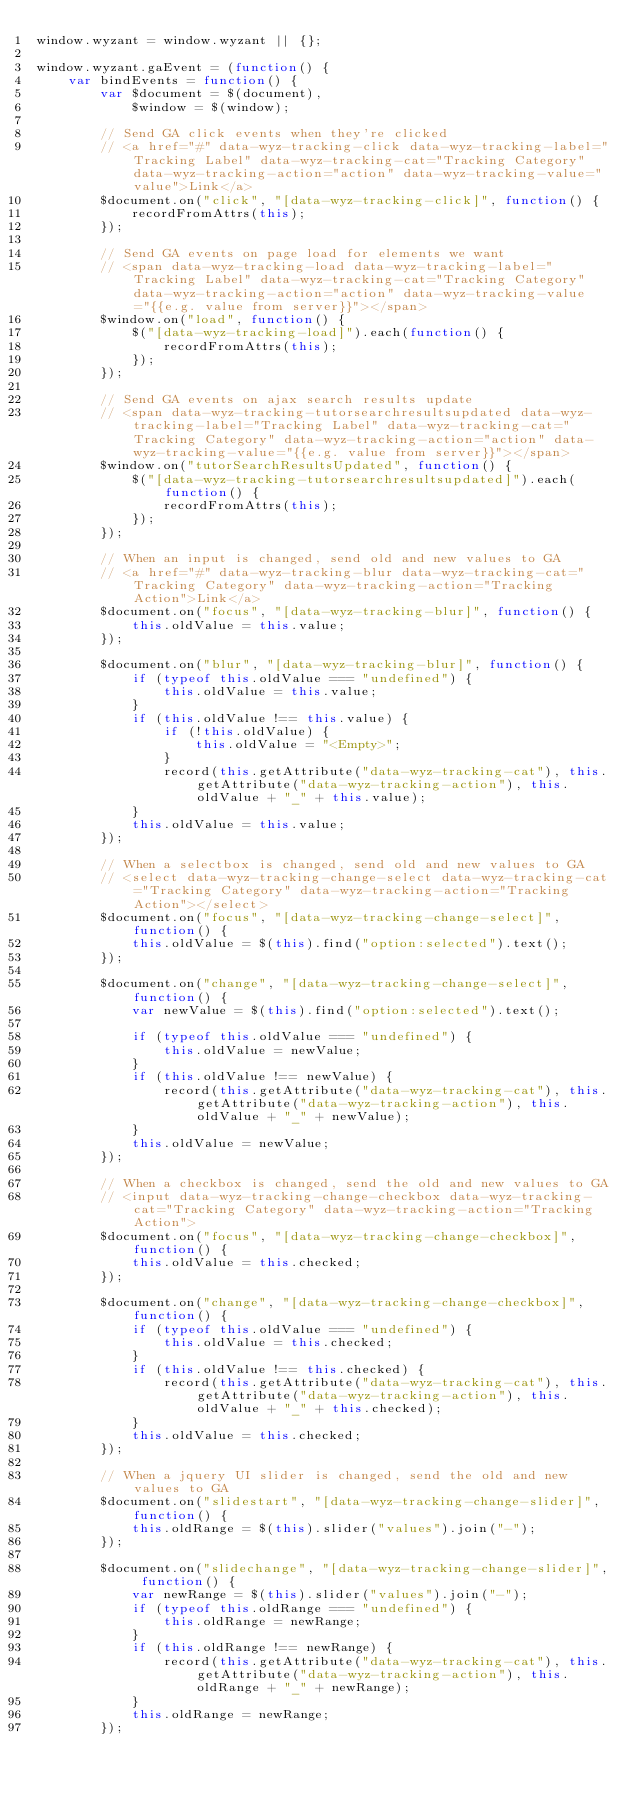<code> <loc_0><loc_0><loc_500><loc_500><_JavaScript_>window.wyzant = window.wyzant || {};

window.wyzant.gaEvent = (function() {
    var bindEvents = function() {
        var $document = $(document),
            $window = $(window);

        // Send GA click events when they're clicked
        // <a href="#" data-wyz-tracking-click data-wyz-tracking-label="Tracking Label" data-wyz-tracking-cat="Tracking Category" data-wyz-tracking-action="action" data-wyz-tracking-value="value">Link</a>
        $document.on("click", "[data-wyz-tracking-click]", function() {
            recordFromAttrs(this);
        });

        // Send GA events on page load for elements we want
        // <span data-wyz-tracking-load data-wyz-tracking-label="Tracking Label" data-wyz-tracking-cat="Tracking Category" data-wyz-tracking-action="action" data-wyz-tracking-value="{{e.g. value from server}}"></span>
        $window.on("load", function() {
            $("[data-wyz-tracking-load]").each(function() {
                recordFromAttrs(this);
            });
        });

        // Send GA events on ajax search results update
        // <span data-wyz-tracking-tutorsearchresultsupdated data-wyz-tracking-label="Tracking Label" data-wyz-tracking-cat="Tracking Category" data-wyz-tracking-action="action" data-wyz-tracking-value="{{e.g. value from server}}"></span>
        $window.on("tutorSearchResultsUpdated", function() {
            $("[data-wyz-tracking-tutorsearchresultsupdated]").each(function() {
                recordFromAttrs(this);
            });
        });

        // When an input is changed, send old and new values to GA
        // <a href="#" data-wyz-tracking-blur data-wyz-tracking-cat="Tracking Category" data-wyz-tracking-action="Tracking Action">Link</a>
        $document.on("focus", "[data-wyz-tracking-blur]", function() {
            this.oldValue = this.value;
        });

        $document.on("blur", "[data-wyz-tracking-blur]", function() {
            if (typeof this.oldValue === "undefined") {
                this.oldValue = this.value;
            }
            if (this.oldValue !== this.value) {
                if (!this.oldValue) {
                    this.oldValue = "<Empty>";
                }
                record(this.getAttribute("data-wyz-tracking-cat"), this.getAttribute("data-wyz-tracking-action"), this.oldValue + "_" + this.value);
            }
            this.oldValue = this.value;
        });

        // When a selectbox is changed, send old and new values to GA
        // <select data-wyz-tracking-change-select data-wyz-tracking-cat="Tracking Category" data-wyz-tracking-action="Tracking Action"></select>
        $document.on("focus", "[data-wyz-tracking-change-select]", function() {
            this.oldValue = $(this).find("option:selected").text();
        });

        $document.on("change", "[data-wyz-tracking-change-select]", function() {
            var newValue = $(this).find("option:selected").text();

            if (typeof this.oldValue === "undefined") {
                this.oldValue = newValue;
            }
            if (this.oldValue !== newValue) {
                record(this.getAttribute("data-wyz-tracking-cat"), this.getAttribute("data-wyz-tracking-action"), this.oldValue + "_" + newValue);
            }
            this.oldValue = newValue;
        });

        // When a checkbox is changed, send the old and new values to GA
        // <input data-wyz-tracking-change-checkbox data-wyz-tracking-cat="Tracking Category" data-wyz-tracking-action="Tracking Action">
        $document.on("focus", "[data-wyz-tracking-change-checkbox]", function() {
            this.oldValue = this.checked;
        });

        $document.on("change", "[data-wyz-tracking-change-checkbox]", function() {
            if (typeof this.oldValue === "undefined") {
                this.oldValue = this.checked;
            }
            if (this.oldValue !== this.checked) {
                record(this.getAttribute("data-wyz-tracking-cat"), this.getAttribute("data-wyz-tracking-action"), this.oldValue + "_" + this.checked);
            }
            this.oldValue = this.checked;
        });

        // When a jquery UI slider is changed, send the old and new values to GA
        $document.on("slidestart", "[data-wyz-tracking-change-slider]", function() {
            this.oldRange = $(this).slider("values").join("-");
        });

        $document.on("slidechange", "[data-wyz-tracking-change-slider]", function() {
            var newRange = $(this).slider("values").join("-");
            if (typeof this.oldRange === "undefined") {
                this.oldRange = newRange;
            }
            if (this.oldRange !== newRange) {
                record(this.getAttribute("data-wyz-tracking-cat"), this.getAttribute("data-wyz-tracking-action"), this.oldRange + "_" + newRange);
            }
            this.oldRange = newRange;
        });
</code> 